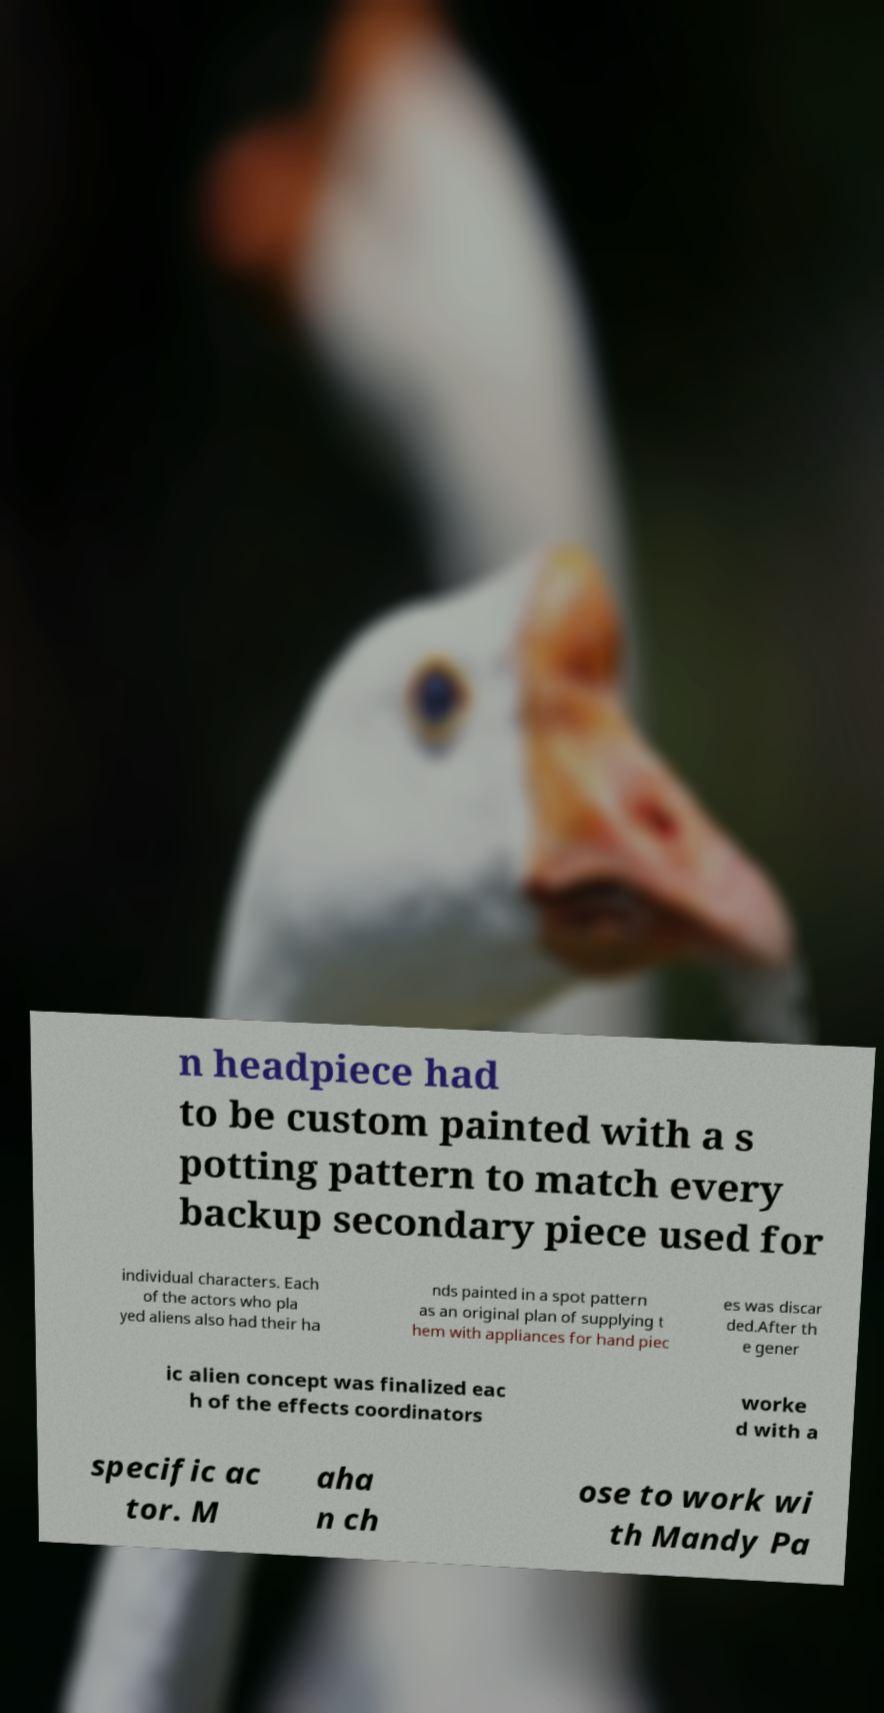Can you accurately transcribe the text from the provided image for me? n headpiece had to be custom painted with a s potting pattern to match every backup secondary piece used for individual characters. Each of the actors who pla yed aliens also had their ha nds painted in a spot pattern as an original plan of supplying t hem with appliances for hand piec es was discar ded.After th e gener ic alien concept was finalized eac h of the effects coordinators worke d with a specific ac tor. M aha n ch ose to work wi th Mandy Pa 